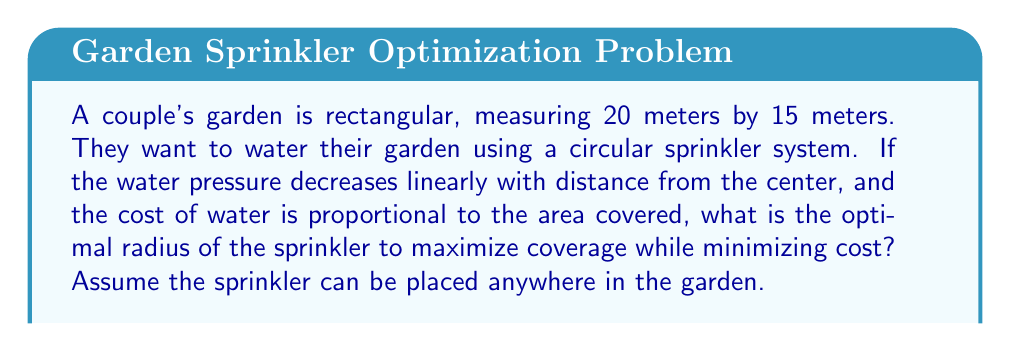Can you solve this math problem? Let's approach this problem step-by-step, like nurturing a relationship:

1) First, we need to define our variables:
   Let $r$ be the radius of the sprinkler coverage.

2) The area of the garden is 20m × 15m = 300m².

3) The area covered by the sprinkler is $A(r) = \pi r^2$.

4) However, we need to consider the effectiveness of the water coverage. As the water pressure decreases linearly with distance, we can model the effectiveness as $(1-\frac{r}{R})$, where $R$ is the maximum possible radius (half the diagonal of the garden).

5) The diagonal of the garden is $\sqrt{20^2 + 15^2} = 25m$, so $R = 12.5m$.

6) Now, we can define our objective function, which represents the effective area covered:

   $$f(r) = \pi r^2 (1-\frac{r}{12.5})$$

7) To find the maximum, we need to differentiate $f(r)$ and set it to zero:

   $$f'(r) = 2\pi r(1-\frac{r}{12.5}) - \frac{\pi r^2}{12.5} = 0$$

8) Simplifying:

   $$2\pi r - \frac{2\pi r^2}{12.5} - \frac{\pi r^2}{12.5} = 0$$
   $$25r - 3r^2 = 0$$
   $$r(25 - 3r) = 0$$

9) Solving this equation:
   $r = 0$ or $r = \frac{25}{3} \approx 8.33m$

10) The second solution, $r \approx 8.33m$, gives us the optimal radius.

11) We can confirm this is a maximum by checking the second derivative is negative at this point.

This optimal radius represents the perfect balance between coverage and cost, much like finding the right balance in a relationship.
Answer: $\frac{25}{3} \approx 8.33$ meters 